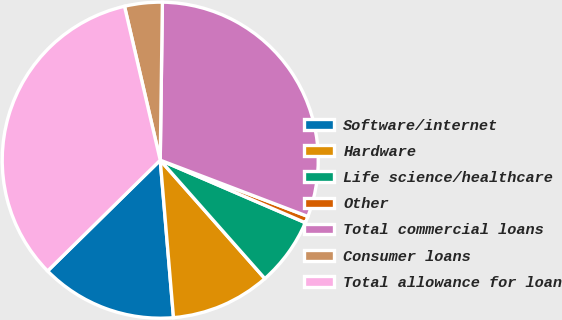Convert chart. <chart><loc_0><loc_0><loc_500><loc_500><pie_chart><fcel>Software/internet<fcel>Hardware<fcel>Life science/healthcare<fcel>Other<fcel>Total commercial loans<fcel>Consumer loans<fcel>Total allowance for loan<nl><fcel>13.97%<fcel>10.18%<fcel>7.01%<fcel>0.68%<fcel>30.58%<fcel>3.85%<fcel>33.74%<nl></chart> 